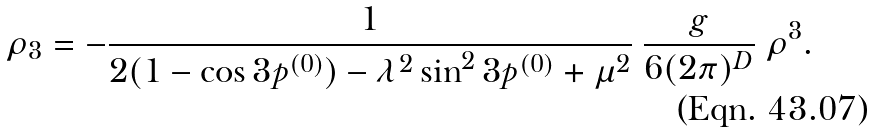<formula> <loc_0><loc_0><loc_500><loc_500>\rho _ { 3 } = - \frac { 1 } { 2 ( 1 - \cos 3 p ^ { ( 0 ) } ) - \lambda ^ { 2 } \sin ^ { 2 } 3 p ^ { ( 0 ) } + \mu ^ { 2 } } \ \frac { g } { 6 ( 2 \pi ) ^ { D } } \ \rho ^ { 3 } .</formula> 